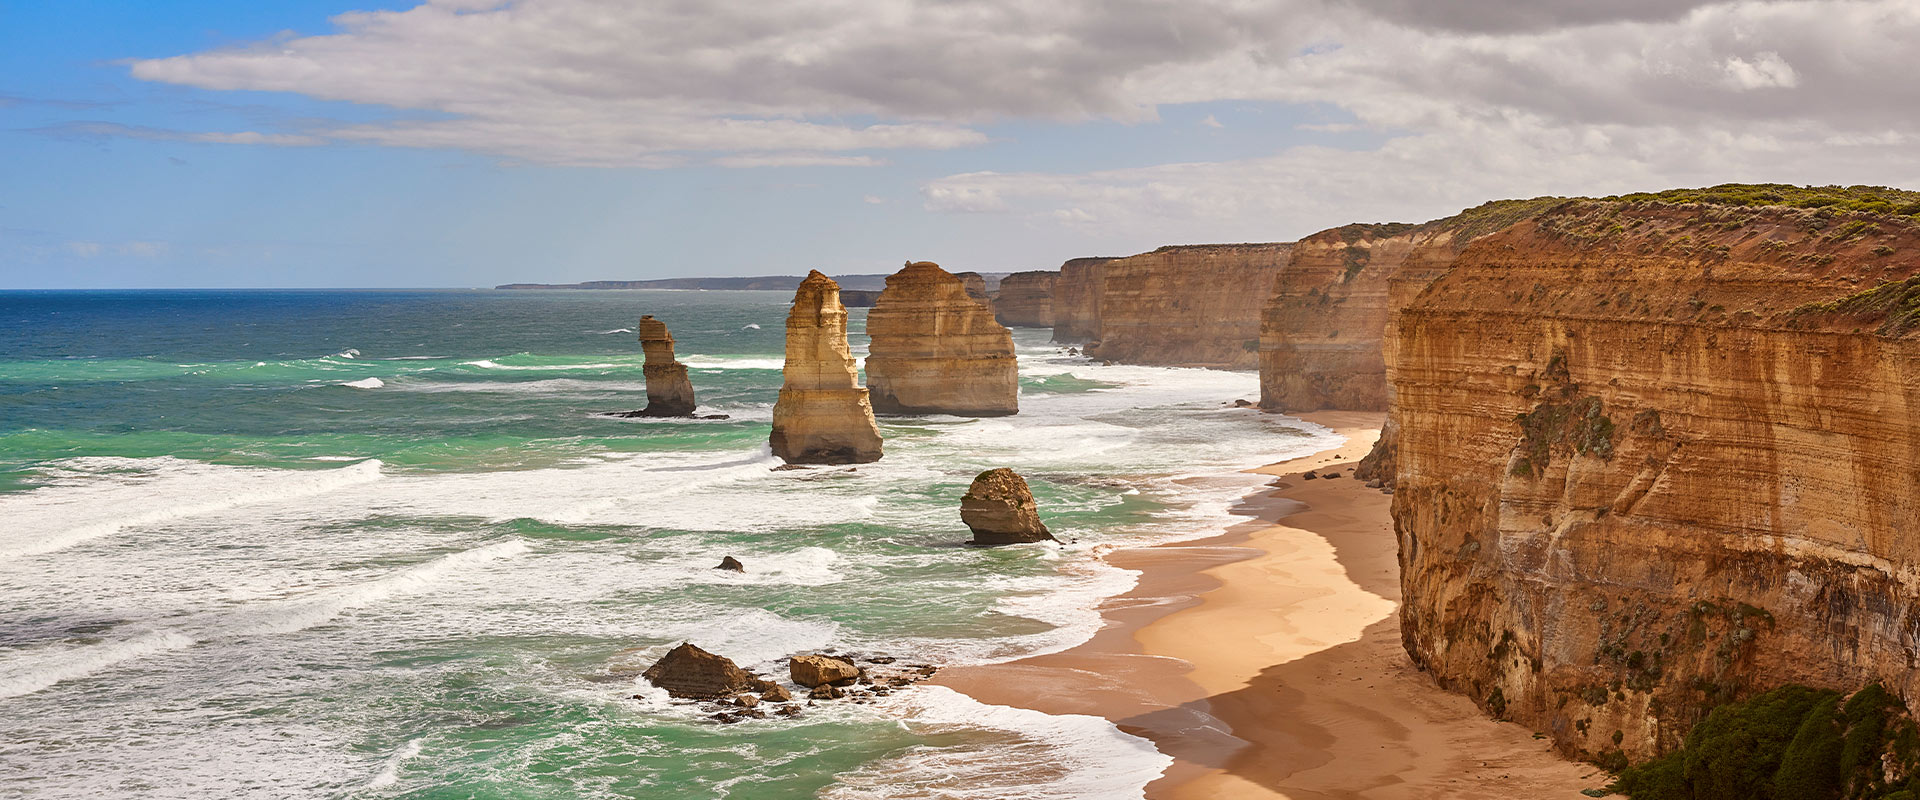What are some human impacts on this area, and what measures are being taken to manage them? The Twelve Apostles, being a popular tourist attraction, face human impact issues such as erosion from foot traffic, littering, and potential harm to the marine environments. In response, measures like designated viewing platforms to minimize direct human contact with sensitive areas, strict littering penalties, and informative campaigns to educate visitors on the importance of conservation are implemented. These efforts aim to balance tourism with environmental responsibility. 